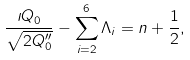<formula> <loc_0><loc_0><loc_500><loc_500>\frac { \imath Q _ { 0 } } { \sqrt { 2 Q _ { 0 } ^ { \prime \prime } } } - \sum _ { i = 2 } ^ { 6 } \Lambda _ { i } = n + \frac { 1 } { 2 } ,</formula> 